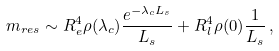<formula> <loc_0><loc_0><loc_500><loc_500>m _ { r e s } \sim R _ { e } ^ { 4 } \rho ( \lambda _ { c } ) \frac { e ^ { - \lambda _ { c } L _ { s } } } { L _ { s } } + R _ { l } ^ { 4 } \rho ( 0 ) \frac { 1 } { L _ { s } } \, ,</formula> 